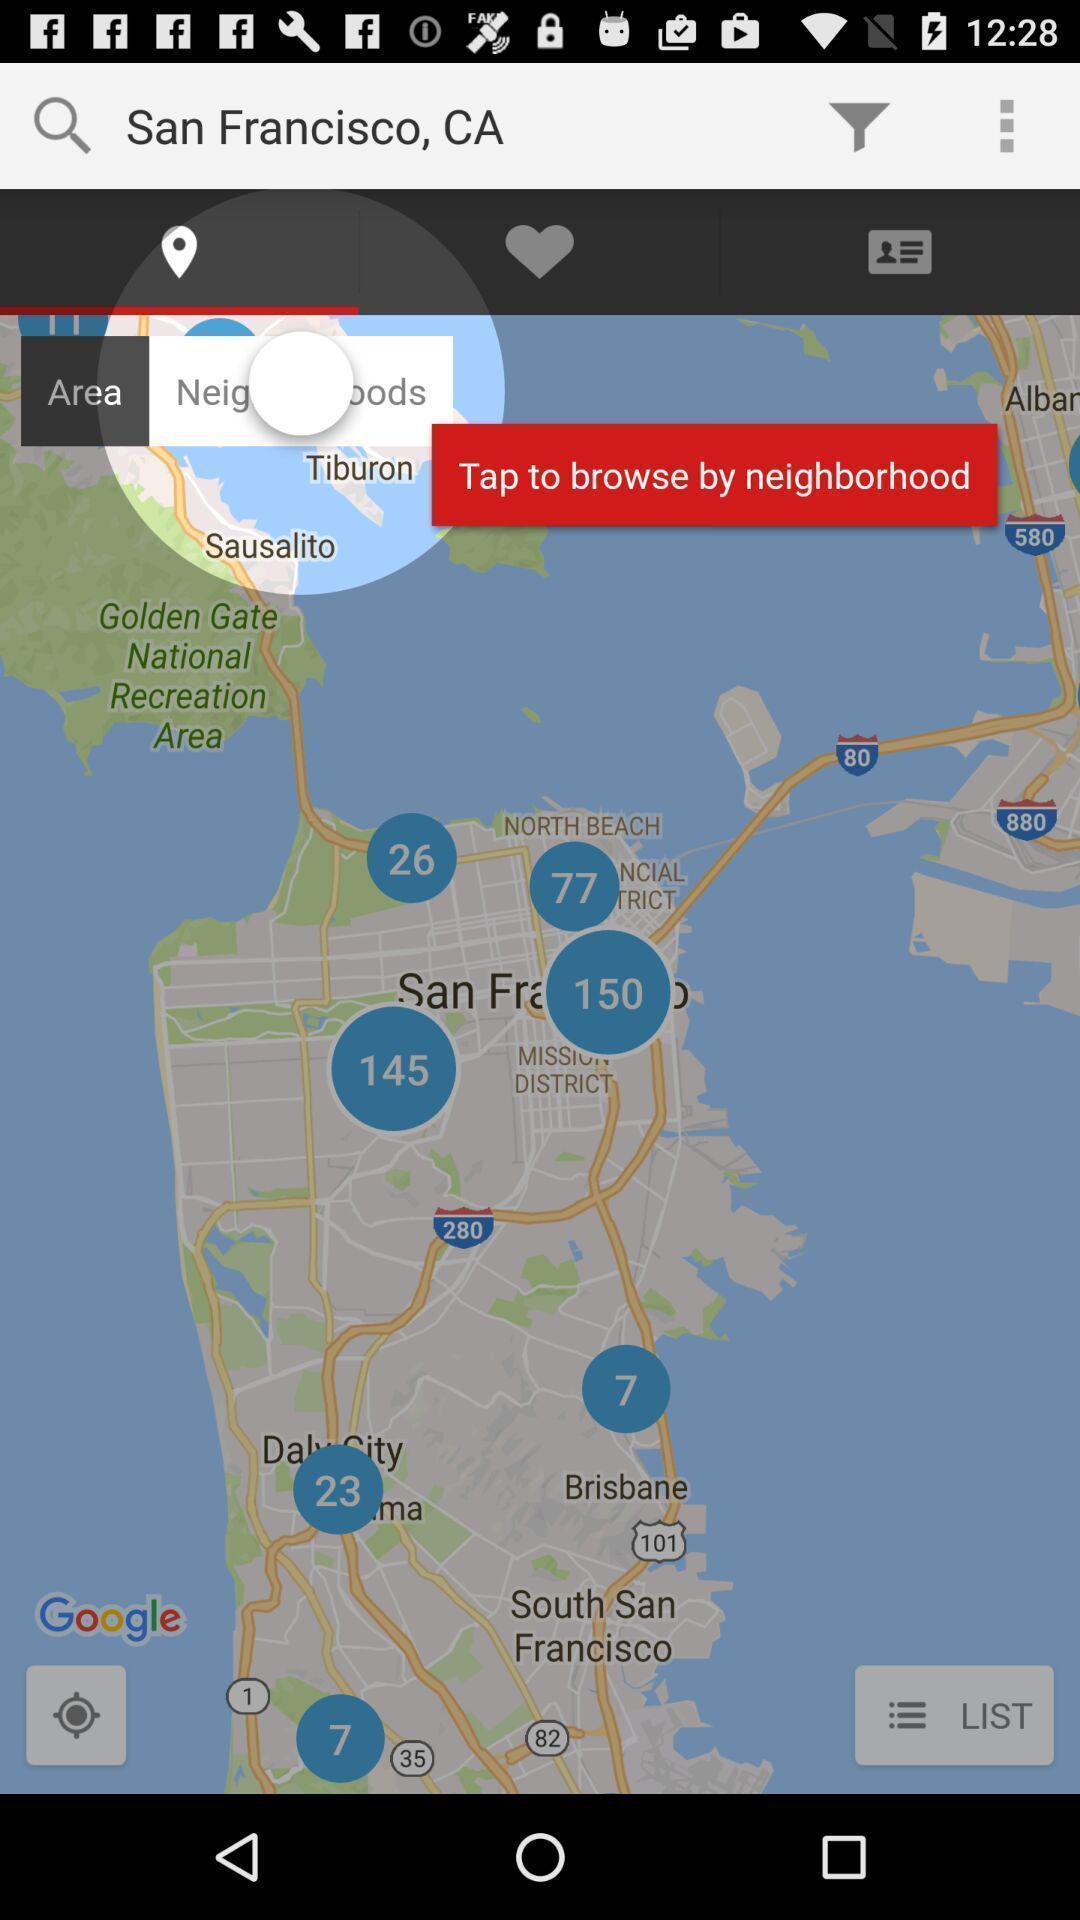Please provide a description for this image. Search bar of a map application. 